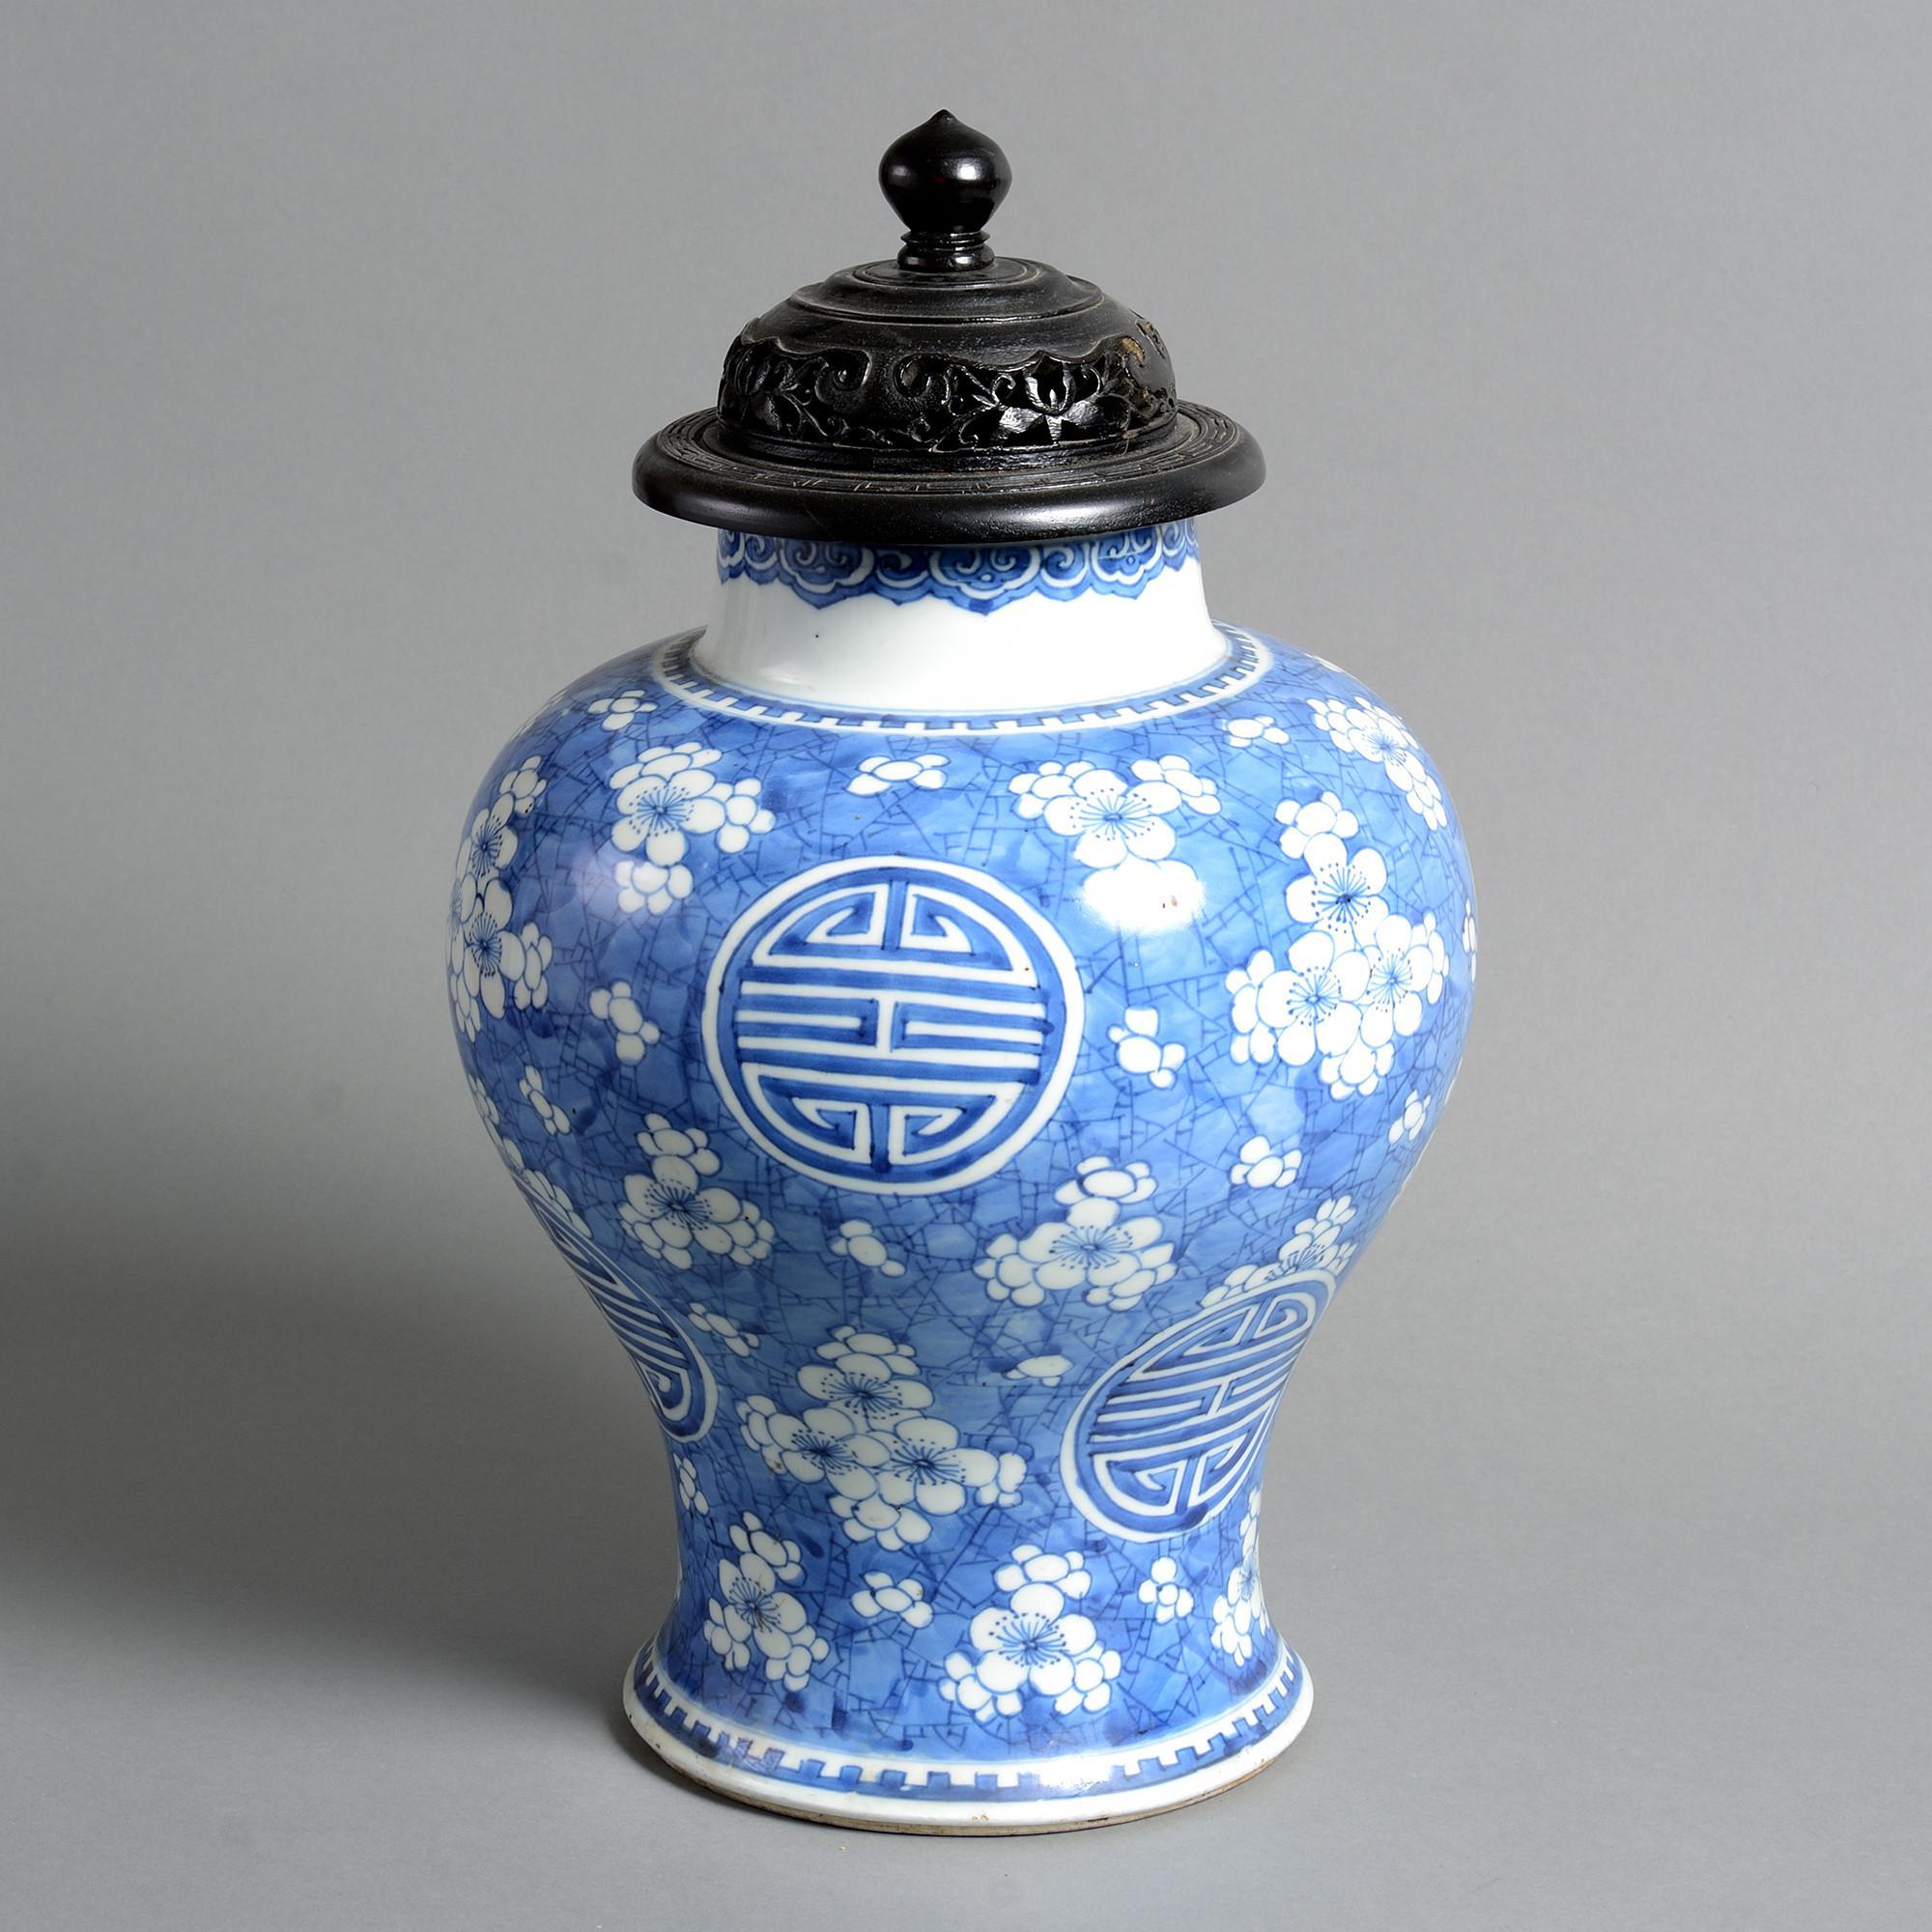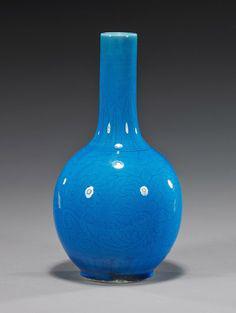The first image is the image on the left, the second image is the image on the right. Analyze the images presented: Is the assertion "A solid blue vase with no markings or texture is in in the right image." valid? Answer yes or no. Yes. The first image is the image on the left, the second image is the image on the right. Analyze the images presented: Is the assertion "One of the images shows a purple vase while the vase in the other image is mostly blue." valid? Answer yes or no. No. 